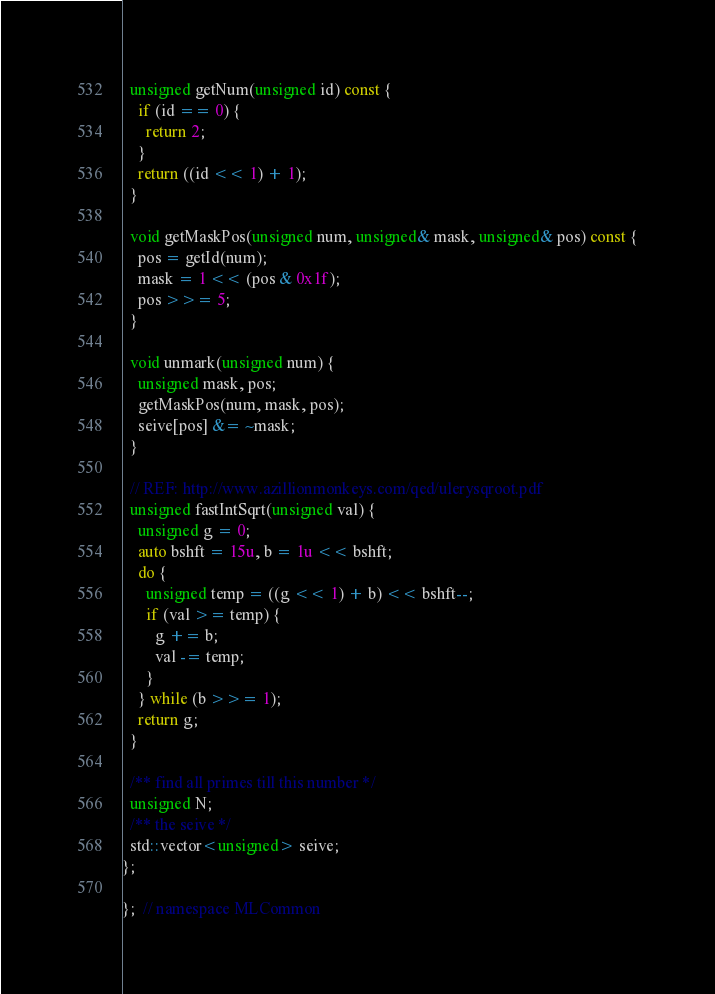<code> <loc_0><loc_0><loc_500><loc_500><_Cuda_>  unsigned getNum(unsigned id) const {
    if (id == 0) {
      return 2;
    }
    return ((id << 1) + 1);
  }

  void getMaskPos(unsigned num, unsigned& mask, unsigned& pos) const {
    pos = getId(num);
    mask = 1 << (pos & 0x1f);
    pos >>= 5;
  }

  void unmark(unsigned num) {
    unsigned mask, pos;
    getMaskPos(num, mask, pos);
    seive[pos] &= ~mask;
  }

  // REF: http://www.azillionmonkeys.com/qed/ulerysqroot.pdf
  unsigned fastIntSqrt(unsigned val) {
    unsigned g = 0;
    auto bshft = 15u, b = 1u << bshft;
    do {
      unsigned temp = ((g << 1) + b) << bshft--;
      if (val >= temp) {
        g += b;
        val -= temp;
      }
    } while (b >>= 1);
    return g;
  }

  /** find all primes till this number */
  unsigned N;
  /** the seive */
  std::vector<unsigned> seive;
};

};  // namespace MLCommon
</code> 